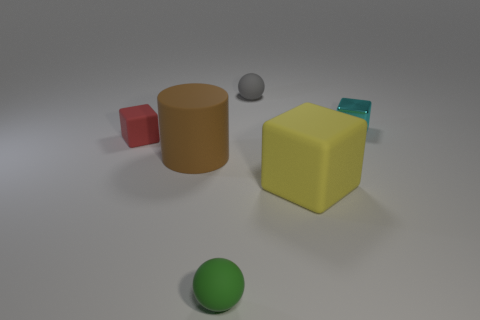What color is the small metal object?
Your answer should be very brief. Cyan. Is there another red block that has the same material as the small red cube?
Provide a short and direct response. No. There is a big cube that is in front of the rubber ball that is behind the small red matte thing; are there any big matte things to the right of it?
Keep it short and to the point. No. There is a gray thing; are there any cylinders right of it?
Offer a very short reply. No. Is there a large matte cylinder that has the same color as the big rubber block?
Your answer should be compact. No. What number of tiny objects are gray rubber cylinders or cyan things?
Provide a succinct answer. 1. Is the material of the cylinder that is in front of the small gray matte thing the same as the big yellow cube?
Give a very brief answer. Yes. What shape is the tiny object behind the small cube to the right of the block that is in front of the large brown matte thing?
Ensure brevity in your answer.  Sphere. How many yellow objects are tiny matte blocks or tiny spheres?
Provide a short and direct response. 0. Are there the same number of yellow cubes on the right side of the small cyan thing and green matte things to the right of the small gray sphere?
Make the answer very short. Yes. 